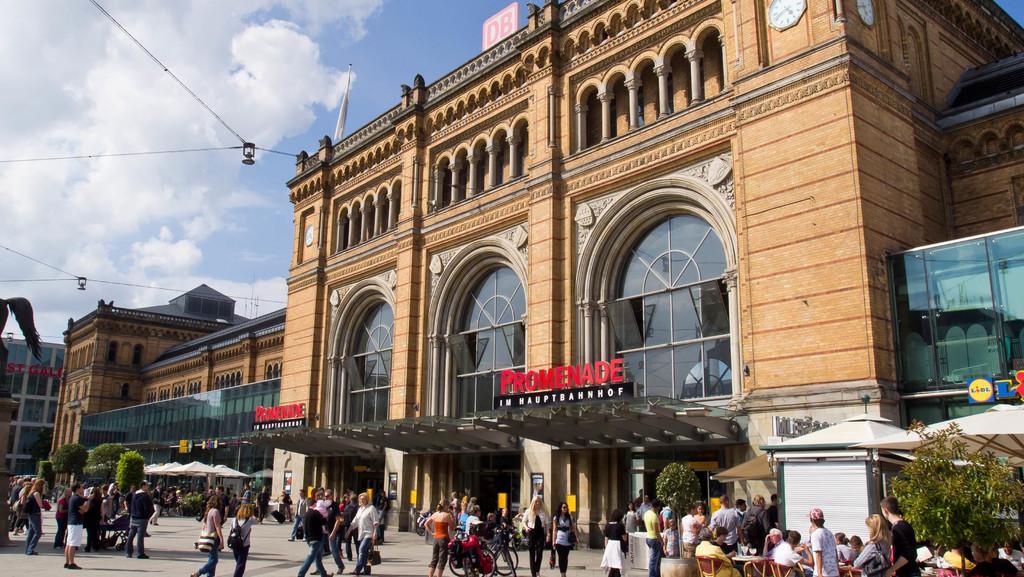How would you summarize this image in a sentence or two? In the foreground of the picture there are people, chairs, tables, bicycle and road. On the left there are buildings, canopies, trees and people. In the center of the picture there is a building. On the right there is a canopy and plant. At the top there are cables and cameras, clouds and sky. 